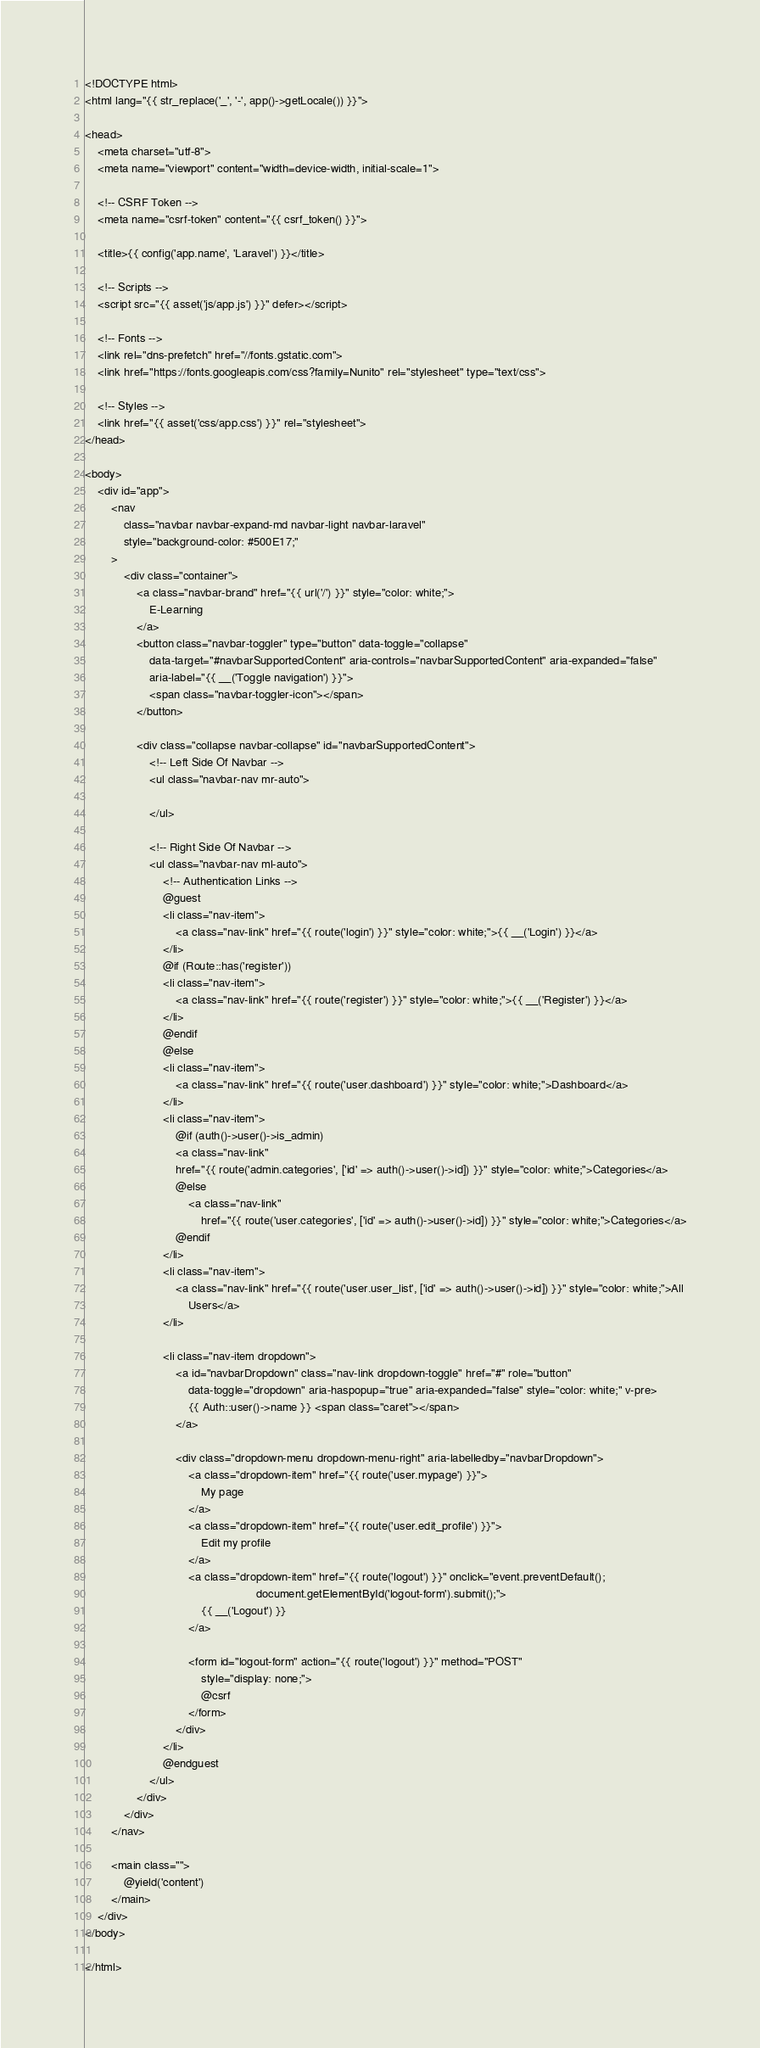Convert code to text. <code><loc_0><loc_0><loc_500><loc_500><_PHP_><!DOCTYPE html>
<html lang="{{ str_replace('_', '-', app()->getLocale()) }}">

<head>
    <meta charset="utf-8">
    <meta name="viewport" content="width=device-width, initial-scale=1">

    <!-- CSRF Token -->
    <meta name="csrf-token" content="{{ csrf_token() }}">

    <title>{{ config('app.name', 'Laravel') }}</title>

    <!-- Scripts -->
    <script src="{{ asset('js/app.js') }}" defer></script>

    <!-- Fonts -->
    <link rel="dns-prefetch" href="//fonts.gstatic.com">
    <link href="https://fonts.googleapis.com/css?family=Nunito" rel="stylesheet" type="text/css">

    <!-- Styles -->
    <link href="{{ asset('css/app.css') }}" rel="stylesheet">
</head>

<body>
    <div id="app">
        <nav 
            class="navbar navbar-expand-md navbar-light navbar-laravel"
            style="background-color: #500E17;"
        >
            <div class="container">
                <a class="navbar-brand" href="{{ url('/') }}" style="color: white;">
                    E-Learning
                </a>
                <button class="navbar-toggler" type="button" data-toggle="collapse"
                    data-target="#navbarSupportedContent" aria-controls="navbarSupportedContent" aria-expanded="false"
                    aria-label="{{ __('Toggle navigation') }}">
                    <span class="navbar-toggler-icon"></span>
                </button>

                <div class="collapse navbar-collapse" id="navbarSupportedContent">
                    <!-- Left Side Of Navbar -->
                    <ul class="navbar-nav mr-auto">

                    </ul>

                    <!-- Right Side Of Navbar -->
                    <ul class="navbar-nav ml-auto">
                        <!-- Authentication Links -->
                        @guest
                        <li class="nav-item">
                            <a class="nav-link" href="{{ route('login') }}" style="color: white;">{{ __('Login') }}</a>
                        </li>
                        @if (Route::has('register'))
                        <li class="nav-item">
                            <a class="nav-link" href="{{ route('register') }}" style="color: white;">{{ __('Register') }}</a>
                        </li>
                        @endif
                        @else
                        <li class="nav-item">
                            <a class="nav-link" href="{{ route('user.dashboard') }}" style="color: white;">Dashboard</a>
                        </li>
                        <li class="nav-item">
                            @if (auth()->user()->is_admin)
                            <a class="nav-link"
                            href="{{ route('admin.categories', ['id' => auth()->user()->id]) }}" style="color: white;">Categories</a>
                            @else
                                <a class="nav-link"
                                    href="{{ route('user.categories', ['id' => auth()->user()->id]) }}" style="color: white;">Categories</a>
                            @endif
                        </li>
                        <li class="nav-item">
                            <a class="nav-link" href="{{ route('user.user_list', ['id' => auth()->user()->id]) }}" style="color: white;">All
                                Users</a>
                        </li>

                        <li class="nav-item dropdown">
                            <a id="navbarDropdown" class="nav-link dropdown-toggle" href="#" role="button"
                                data-toggle="dropdown" aria-haspopup="true" aria-expanded="false" style="color: white;" v-pre>
                                {{ Auth::user()->name }} <span class="caret"></span>
                            </a>

                            <div class="dropdown-menu dropdown-menu-right" aria-labelledby="navbarDropdown">
                                <a class="dropdown-item" href="{{ route('user.mypage') }}">
                                    My page
                                </a>
                                <a class="dropdown-item" href="{{ route('user.edit_profile') }}">
                                    Edit my profile
                                </a>
                                <a class="dropdown-item" href="{{ route('logout') }}" onclick="event.preventDefault();
                                                     document.getElementById('logout-form').submit();">
                                    {{ __('Logout') }}
                                </a>

                                <form id="logout-form" action="{{ route('logout') }}" method="POST"
                                    style="display: none;">
                                    @csrf
                                </form>
                            </div>
                        </li>
                        @endguest
                    </ul>
                </div>
            </div>
        </nav>

        <main class="">
            @yield('content')
        </main>
    </div>
</body>

</html></code> 